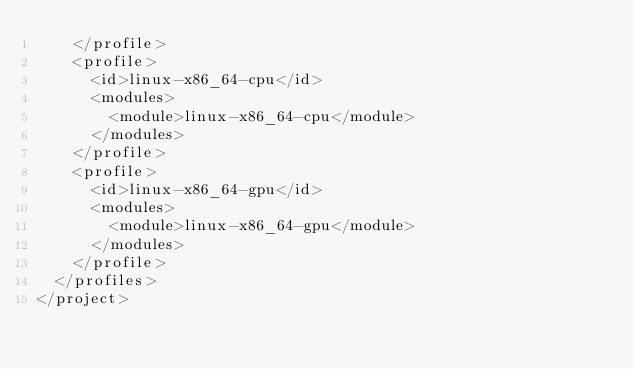Convert code to text. <code><loc_0><loc_0><loc_500><loc_500><_XML_>    </profile>
    <profile>
      <id>linux-x86_64-cpu</id>
      <modules>
        <module>linux-x86_64-cpu</module>
      </modules>
    </profile>
    <profile>
      <id>linux-x86_64-gpu</id>
      <modules>
        <module>linux-x86_64-gpu</module>
      </modules>
    </profile>
  </profiles>
</project>
</code> 